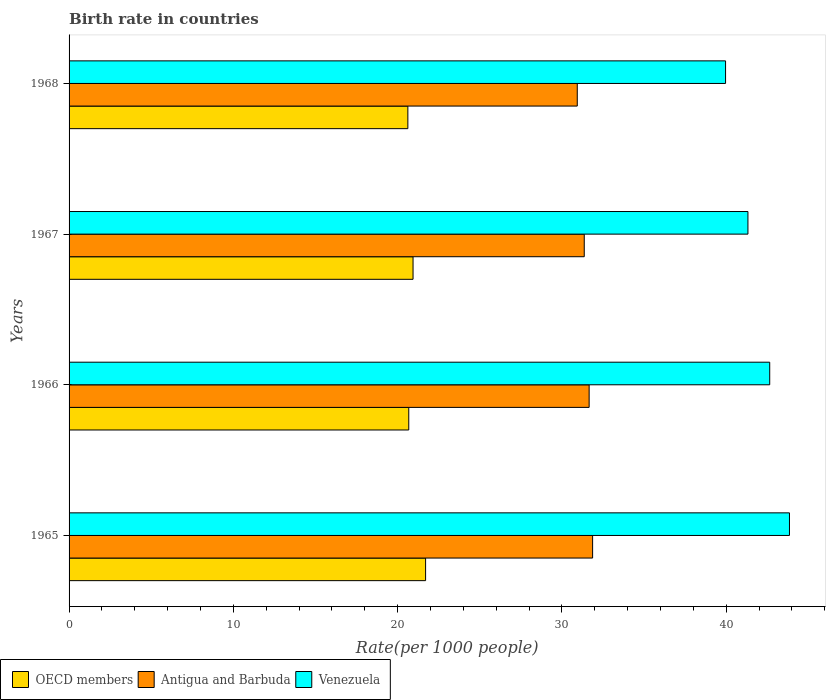How many different coloured bars are there?
Give a very brief answer. 3. How many groups of bars are there?
Offer a terse response. 4. Are the number of bars on each tick of the Y-axis equal?
Provide a short and direct response. Yes. What is the label of the 3rd group of bars from the top?
Make the answer very short. 1966. In how many cases, is the number of bars for a given year not equal to the number of legend labels?
Keep it short and to the point. 0. What is the birth rate in OECD members in 1966?
Offer a terse response. 20.68. Across all years, what is the maximum birth rate in Antigua and Barbuda?
Keep it short and to the point. 31.87. Across all years, what is the minimum birth rate in Venezuela?
Provide a short and direct response. 39.96. In which year was the birth rate in OECD members maximum?
Offer a very short reply. 1965. In which year was the birth rate in OECD members minimum?
Make the answer very short. 1968. What is the total birth rate in Antigua and Barbuda in the graph?
Make the answer very short. 125.81. What is the difference between the birth rate in Venezuela in 1966 and that in 1968?
Offer a terse response. 2.69. What is the difference between the birth rate in Antigua and Barbuda in 1967 and the birth rate in Venezuela in 1968?
Keep it short and to the point. -8.6. What is the average birth rate in OECD members per year?
Keep it short and to the point. 20.98. In the year 1966, what is the difference between the birth rate in Venezuela and birth rate in OECD members?
Provide a short and direct response. 21.97. What is the ratio of the birth rate in Venezuela in 1966 to that in 1968?
Offer a very short reply. 1.07. Is the birth rate in OECD members in 1966 less than that in 1967?
Provide a short and direct response. Yes. What is the difference between the highest and the second highest birth rate in Antigua and Barbuda?
Make the answer very short. 0.21. What is the difference between the highest and the lowest birth rate in Antigua and Barbuda?
Offer a very short reply. 0.93. Is the sum of the birth rate in Venezuela in 1965 and 1966 greater than the maximum birth rate in Antigua and Barbuda across all years?
Provide a succinct answer. Yes. What does the 2nd bar from the top in 1966 represents?
Make the answer very short. Antigua and Barbuda. What does the 3rd bar from the bottom in 1967 represents?
Ensure brevity in your answer.  Venezuela. How many bars are there?
Offer a very short reply. 12. What is the difference between two consecutive major ticks on the X-axis?
Keep it short and to the point. 10. Are the values on the major ticks of X-axis written in scientific E-notation?
Give a very brief answer. No. Does the graph contain any zero values?
Provide a succinct answer. No. Where does the legend appear in the graph?
Your response must be concise. Bottom left. How many legend labels are there?
Your answer should be compact. 3. How are the legend labels stacked?
Your answer should be very brief. Horizontal. What is the title of the graph?
Give a very brief answer. Birth rate in countries. What is the label or title of the X-axis?
Your response must be concise. Rate(per 1000 people). What is the label or title of the Y-axis?
Keep it short and to the point. Years. What is the Rate(per 1000 people) in OECD members in 1965?
Your answer should be very brief. 21.7. What is the Rate(per 1000 people) in Antigua and Barbuda in 1965?
Offer a very short reply. 31.87. What is the Rate(per 1000 people) in Venezuela in 1965?
Give a very brief answer. 43.85. What is the Rate(per 1000 people) of OECD members in 1966?
Make the answer very short. 20.68. What is the Rate(per 1000 people) of Antigua and Barbuda in 1966?
Keep it short and to the point. 31.66. What is the Rate(per 1000 people) of Venezuela in 1966?
Your answer should be very brief. 42.65. What is the Rate(per 1000 people) of OECD members in 1967?
Offer a very short reply. 20.94. What is the Rate(per 1000 people) of Antigua and Barbuda in 1967?
Offer a terse response. 31.36. What is the Rate(per 1000 people) in Venezuela in 1967?
Your response must be concise. 41.32. What is the Rate(per 1000 people) of OECD members in 1968?
Make the answer very short. 20.62. What is the Rate(per 1000 people) of Antigua and Barbuda in 1968?
Offer a very short reply. 30.93. What is the Rate(per 1000 people) of Venezuela in 1968?
Your answer should be compact. 39.96. Across all years, what is the maximum Rate(per 1000 people) of OECD members?
Offer a very short reply. 21.7. Across all years, what is the maximum Rate(per 1000 people) in Antigua and Barbuda?
Provide a succinct answer. 31.87. Across all years, what is the maximum Rate(per 1000 people) of Venezuela?
Keep it short and to the point. 43.85. Across all years, what is the minimum Rate(per 1000 people) in OECD members?
Your answer should be very brief. 20.62. Across all years, what is the minimum Rate(per 1000 people) in Antigua and Barbuda?
Ensure brevity in your answer.  30.93. Across all years, what is the minimum Rate(per 1000 people) of Venezuela?
Your answer should be very brief. 39.96. What is the total Rate(per 1000 people) in OECD members in the graph?
Offer a very short reply. 83.93. What is the total Rate(per 1000 people) of Antigua and Barbuda in the graph?
Ensure brevity in your answer.  125.81. What is the total Rate(per 1000 people) of Venezuela in the graph?
Make the answer very short. 167.78. What is the difference between the Rate(per 1000 people) of OECD members in 1965 and that in 1966?
Offer a terse response. 1.02. What is the difference between the Rate(per 1000 people) of Antigua and Barbuda in 1965 and that in 1966?
Make the answer very short. 0.21. What is the difference between the Rate(per 1000 people) in Venezuela in 1965 and that in 1966?
Provide a short and direct response. 1.2. What is the difference between the Rate(per 1000 people) in OECD members in 1965 and that in 1967?
Make the answer very short. 0.76. What is the difference between the Rate(per 1000 people) of Antigua and Barbuda in 1965 and that in 1967?
Your answer should be very brief. 0.51. What is the difference between the Rate(per 1000 people) of Venezuela in 1965 and that in 1967?
Make the answer very short. 2.53. What is the difference between the Rate(per 1000 people) of OECD members in 1965 and that in 1968?
Offer a terse response. 1.08. What is the difference between the Rate(per 1000 people) of Antigua and Barbuda in 1965 and that in 1968?
Offer a terse response. 0.93. What is the difference between the Rate(per 1000 people) of Venezuela in 1965 and that in 1968?
Keep it short and to the point. 3.89. What is the difference between the Rate(per 1000 people) of OECD members in 1966 and that in 1967?
Your answer should be very brief. -0.26. What is the difference between the Rate(per 1000 people) in Antigua and Barbuda in 1966 and that in 1967?
Your response must be concise. 0.3. What is the difference between the Rate(per 1000 people) of Venezuela in 1966 and that in 1967?
Provide a short and direct response. 1.33. What is the difference between the Rate(per 1000 people) in OECD members in 1966 and that in 1968?
Offer a terse response. 0.06. What is the difference between the Rate(per 1000 people) in Antigua and Barbuda in 1966 and that in 1968?
Offer a terse response. 0.72. What is the difference between the Rate(per 1000 people) in Venezuela in 1966 and that in 1968?
Give a very brief answer. 2.69. What is the difference between the Rate(per 1000 people) in OECD members in 1967 and that in 1968?
Provide a succinct answer. 0.32. What is the difference between the Rate(per 1000 people) in Antigua and Barbuda in 1967 and that in 1968?
Your answer should be very brief. 0.42. What is the difference between the Rate(per 1000 people) of Venezuela in 1967 and that in 1968?
Offer a terse response. 1.36. What is the difference between the Rate(per 1000 people) of OECD members in 1965 and the Rate(per 1000 people) of Antigua and Barbuda in 1966?
Give a very brief answer. -9.95. What is the difference between the Rate(per 1000 people) of OECD members in 1965 and the Rate(per 1000 people) of Venezuela in 1966?
Make the answer very short. -20.95. What is the difference between the Rate(per 1000 people) of Antigua and Barbuda in 1965 and the Rate(per 1000 people) of Venezuela in 1966?
Keep it short and to the point. -10.78. What is the difference between the Rate(per 1000 people) of OECD members in 1965 and the Rate(per 1000 people) of Antigua and Barbuda in 1967?
Ensure brevity in your answer.  -9.66. What is the difference between the Rate(per 1000 people) of OECD members in 1965 and the Rate(per 1000 people) of Venezuela in 1967?
Provide a short and direct response. -19.62. What is the difference between the Rate(per 1000 people) in Antigua and Barbuda in 1965 and the Rate(per 1000 people) in Venezuela in 1967?
Offer a terse response. -9.46. What is the difference between the Rate(per 1000 people) in OECD members in 1965 and the Rate(per 1000 people) in Antigua and Barbuda in 1968?
Give a very brief answer. -9.23. What is the difference between the Rate(per 1000 people) in OECD members in 1965 and the Rate(per 1000 people) in Venezuela in 1968?
Provide a short and direct response. -18.26. What is the difference between the Rate(per 1000 people) of Antigua and Barbuda in 1965 and the Rate(per 1000 people) of Venezuela in 1968?
Your answer should be compact. -8.09. What is the difference between the Rate(per 1000 people) of OECD members in 1966 and the Rate(per 1000 people) of Antigua and Barbuda in 1967?
Ensure brevity in your answer.  -10.68. What is the difference between the Rate(per 1000 people) of OECD members in 1966 and the Rate(per 1000 people) of Venezuela in 1967?
Offer a very short reply. -20.64. What is the difference between the Rate(per 1000 people) in Antigua and Barbuda in 1966 and the Rate(per 1000 people) in Venezuela in 1967?
Give a very brief answer. -9.67. What is the difference between the Rate(per 1000 people) of OECD members in 1966 and the Rate(per 1000 people) of Antigua and Barbuda in 1968?
Keep it short and to the point. -10.26. What is the difference between the Rate(per 1000 people) of OECD members in 1966 and the Rate(per 1000 people) of Venezuela in 1968?
Give a very brief answer. -19.28. What is the difference between the Rate(per 1000 people) of Antigua and Barbuda in 1966 and the Rate(per 1000 people) of Venezuela in 1968?
Your answer should be very brief. -8.3. What is the difference between the Rate(per 1000 people) of OECD members in 1967 and the Rate(per 1000 people) of Antigua and Barbuda in 1968?
Provide a short and direct response. -10. What is the difference between the Rate(per 1000 people) of OECD members in 1967 and the Rate(per 1000 people) of Venezuela in 1968?
Your response must be concise. -19.02. What is the difference between the Rate(per 1000 people) in Antigua and Barbuda in 1967 and the Rate(per 1000 people) in Venezuela in 1968?
Your answer should be very brief. -8.6. What is the average Rate(per 1000 people) of OECD members per year?
Make the answer very short. 20.98. What is the average Rate(per 1000 people) of Antigua and Barbuda per year?
Provide a short and direct response. 31.45. What is the average Rate(per 1000 people) in Venezuela per year?
Make the answer very short. 41.94. In the year 1965, what is the difference between the Rate(per 1000 people) in OECD members and Rate(per 1000 people) in Antigua and Barbuda?
Provide a succinct answer. -10.17. In the year 1965, what is the difference between the Rate(per 1000 people) in OECD members and Rate(per 1000 people) in Venezuela?
Give a very brief answer. -22.15. In the year 1965, what is the difference between the Rate(per 1000 people) of Antigua and Barbuda and Rate(per 1000 people) of Venezuela?
Give a very brief answer. -11.98. In the year 1966, what is the difference between the Rate(per 1000 people) of OECD members and Rate(per 1000 people) of Antigua and Barbuda?
Keep it short and to the point. -10.98. In the year 1966, what is the difference between the Rate(per 1000 people) in OECD members and Rate(per 1000 people) in Venezuela?
Keep it short and to the point. -21.97. In the year 1966, what is the difference between the Rate(per 1000 people) in Antigua and Barbuda and Rate(per 1000 people) in Venezuela?
Provide a short and direct response. -10.99. In the year 1967, what is the difference between the Rate(per 1000 people) in OECD members and Rate(per 1000 people) in Antigua and Barbuda?
Ensure brevity in your answer.  -10.42. In the year 1967, what is the difference between the Rate(per 1000 people) of OECD members and Rate(per 1000 people) of Venezuela?
Your answer should be compact. -20.38. In the year 1967, what is the difference between the Rate(per 1000 people) in Antigua and Barbuda and Rate(per 1000 people) in Venezuela?
Offer a terse response. -9.96. In the year 1968, what is the difference between the Rate(per 1000 people) in OECD members and Rate(per 1000 people) in Antigua and Barbuda?
Make the answer very short. -10.31. In the year 1968, what is the difference between the Rate(per 1000 people) in OECD members and Rate(per 1000 people) in Venezuela?
Provide a short and direct response. -19.34. In the year 1968, what is the difference between the Rate(per 1000 people) in Antigua and Barbuda and Rate(per 1000 people) in Venezuela?
Keep it short and to the point. -9.03. What is the ratio of the Rate(per 1000 people) of OECD members in 1965 to that in 1966?
Your response must be concise. 1.05. What is the ratio of the Rate(per 1000 people) in Venezuela in 1965 to that in 1966?
Provide a succinct answer. 1.03. What is the ratio of the Rate(per 1000 people) in OECD members in 1965 to that in 1967?
Make the answer very short. 1.04. What is the ratio of the Rate(per 1000 people) in Antigua and Barbuda in 1965 to that in 1967?
Your response must be concise. 1.02. What is the ratio of the Rate(per 1000 people) in Venezuela in 1965 to that in 1967?
Keep it short and to the point. 1.06. What is the ratio of the Rate(per 1000 people) of OECD members in 1965 to that in 1968?
Make the answer very short. 1.05. What is the ratio of the Rate(per 1000 people) in Antigua and Barbuda in 1965 to that in 1968?
Provide a short and direct response. 1.03. What is the ratio of the Rate(per 1000 people) in Venezuela in 1965 to that in 1968?
Provide a succinct answer. 1.1. What is the ratio of the Rate(per 1000 people) of OECD members in 1966 to that in 1967?
Your answer should be compact. 0.99. What is the ratio of the Rate(per 1000 people) of Antigua and Barbuda in 1966 to that in 1967?
Your response must be concise. 1.01. What is the ratio of the Rate(per 1000 people) in Venezuela in 1966 to that in 1967?
Your answer should be very brief. 1.03. What is the ratio of the Rate(per 1000 people) in Antigua and Barbuda in 1966 to that in 1968?
Make the answer very short. 1.02. What is the ratio of the Rate(per 1000 people) of Venezuela in 1966 to that in 1968?
Offer a very short reply. 1.07. What is the ratio of the Rate(per 1000 people) of OECD members in 1967 to that in 1968?
Provide a short and direct response. 1.02. What is the ratio of the Rate(per 1000 people) of Antigua and Barbuda in 1967 to that in 1968?
Provide a short and direct response. 1.01. What is the ratio of the Rate(per 1000 people) of Venezuela in 1967 to that in 1968?
Offer a very short reply. 1.03. What is the difference between the highest and the second highest Rate(per 1000 people) of OECD members?
Offer a very short reply. 0.76. What is the difference between the highest and the second highest Rate(per 1000 people) of Antigua and Barbuda?
Offer a terse response. 0.21. What is the difference between the highest and the second highest Rate(per 1000 people) in Venezuela?
Make the answer very short. 1.2. What is the difference between the highest and the lowest Rate(per 1000 people) of OECD members?
Your answer should be compact. 1.08. What is the difference between the highest and the lowest Rate(per 1000 people) of Antigua and Barbuda?
Make the answer very short. 0.93. What is the difference between the highest and the lowest Rate(per 1000 people) of Venezuela?
Give a very brief answer. 3.89. 